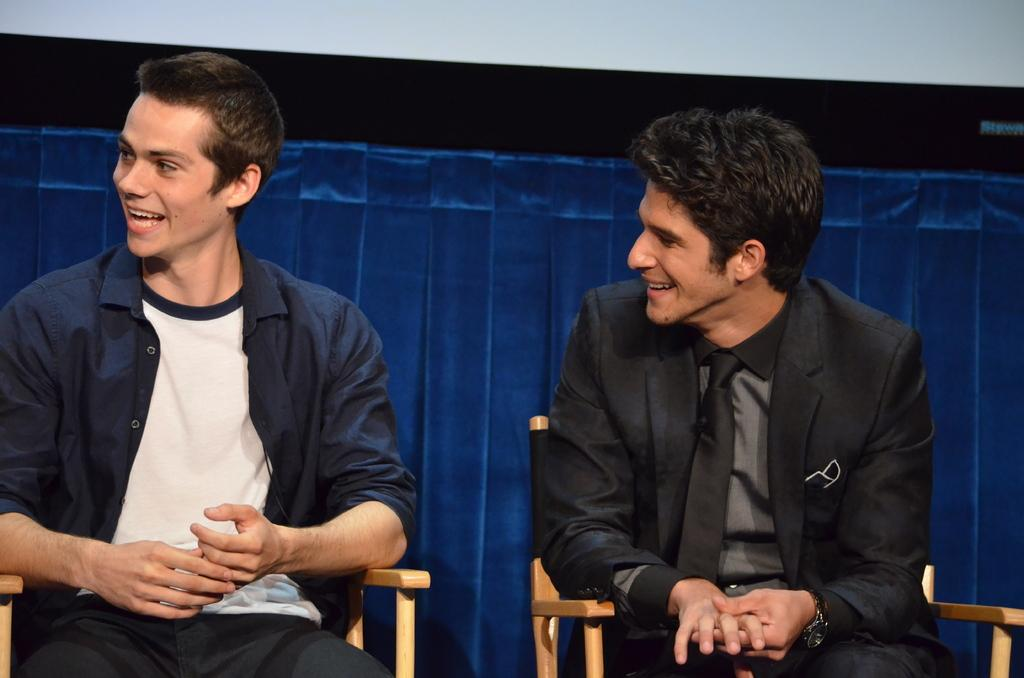How many people are in the image? There are two men in the image. What are the men doing in the image? The men are sitting in the image. What expression do the men have in the image? The men are smiling in the image. What can be seen behind the men in the image? There is a blue color curtain behind the men. What type of growth can be seen on the drum in the image? There is no drum present in the image, so there is no growth to observe. 